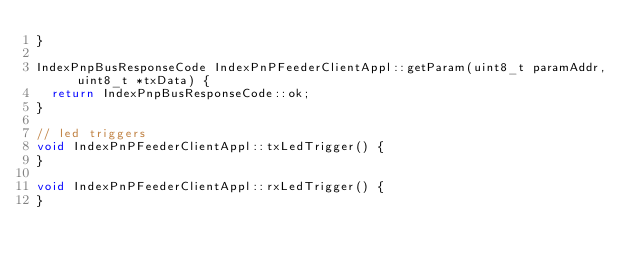Convert code to text. <code><loc_0><loc_0><loc_500><loc_500><_C++_>}

IndexPnpBusResponseCode IndexPnPFeederClientAppl::getParam(uint8_t paramAddr, uint8_t *txData) {
  return IndexPnpBusResponseCode::ok;
}

// led triggers
void IndexPnPFeederClientAppl::txLedTrigger() {
}

void IndexPnPFeederClientAppl::rxLedTrigger() {
}
</code> 